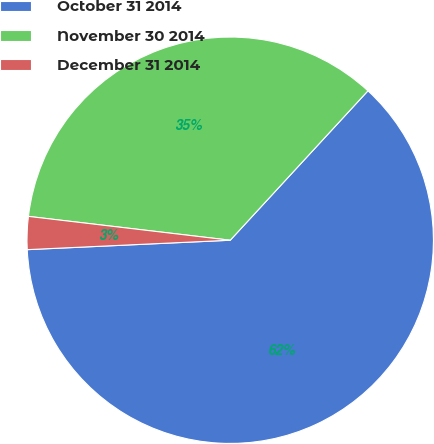Convert chart. <chart><loc_0><loc_0><loc_500><loc_500><pie_chart><fcel>October 31 2014<fcel>November 30 2014<fcel>December 31 2014<nl><fcel>62.41%<fcel>34.98%<fcel>2.61%<nl></chart> 